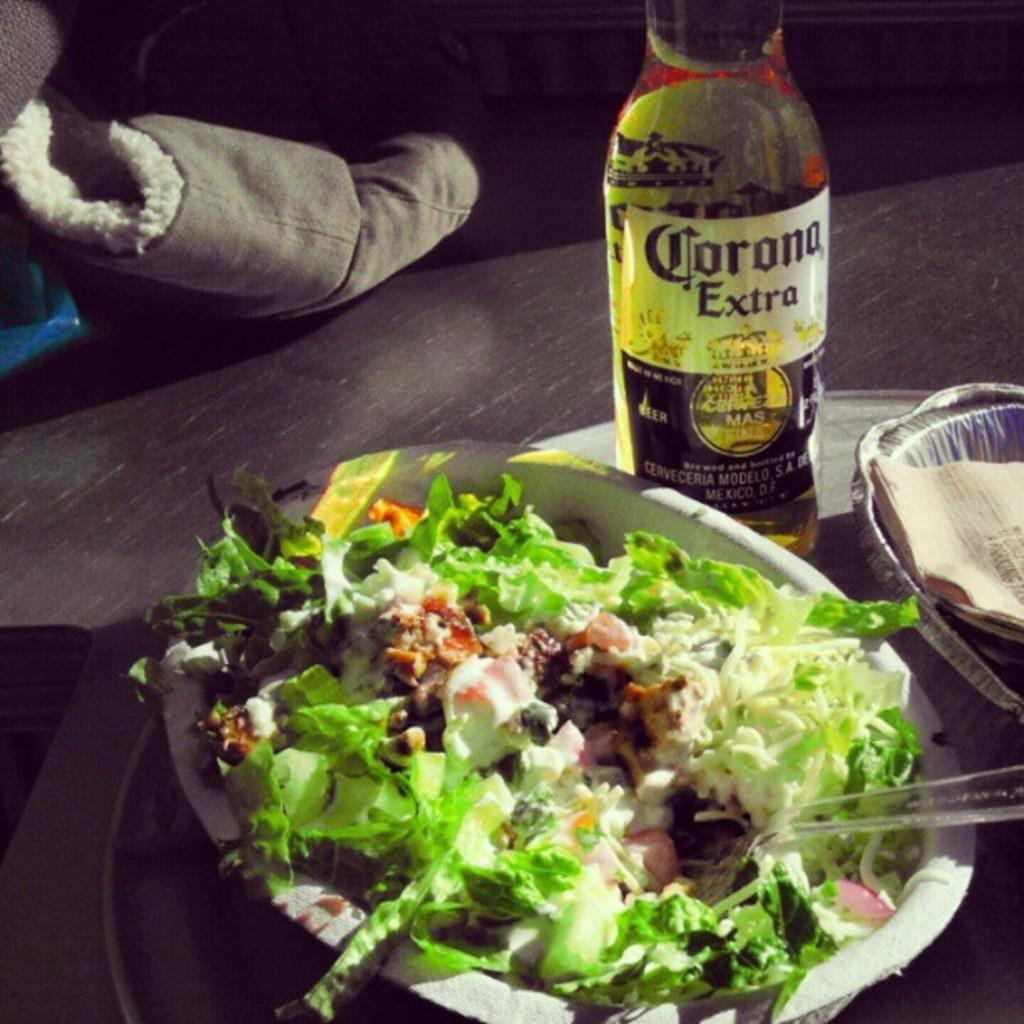What is present on the table in the image? There is food and a bottle on the table in the image. Can you describe the food in the image? Unfortunately, the specific type of food cannot be determined from the provided facts. What is the bottle used for? The purpose of the bottle cannot be determined from the provided facts. What type of engine is visible in the image? There is no engine present in the image. How does the twist affect the food in the image? There is no twist mentioned in the provided facts, and therefore no such effect can be observed. 